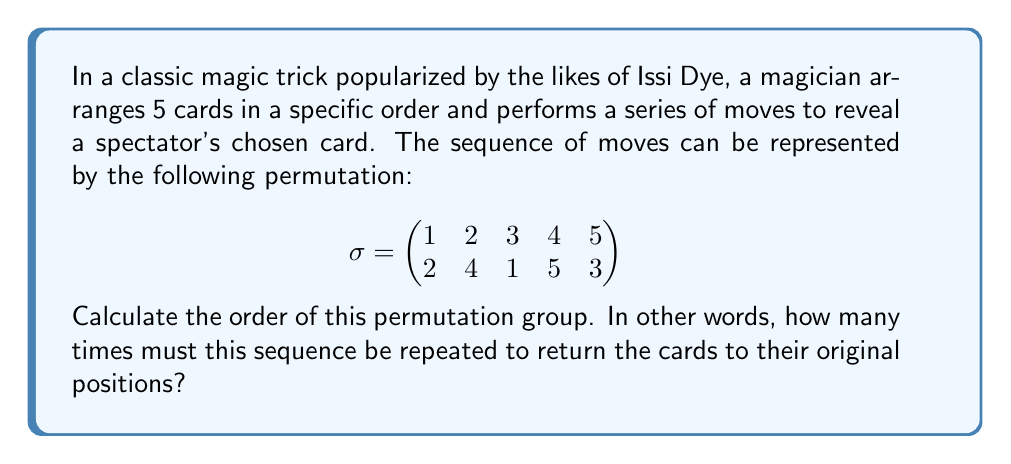What is the answer to this math problem? To find the order of the permutation group, we need to determine the least common multiple (LCM) of the cycle lengths in the permutation. Let's break this down step-by-step:

1) First, let's write the permutation in cycle notation:
   $\sigma = (1 2 4 5 3)$

2) We can see that this is a single cycle of length 5.

3) The order of a single cycle is equal to its length. In this case, the order is 5.

4) Since there's only one cycle, we don't need to calculate the LCM with any other cycle lengths.

5) Therefore, the permutation will return to the identity after being applied 5 times.

We can verify this:
$\sigma^1 = (1 2 4 5 3)$
$\sigma^2 = (1 4 3 2 5)$
$\sigma^3 = (1 5 2 3 4)$
$\sigma^4 = (1 3 5 4 2)$
$\sigma^5 = (1)(2)(3)(4)(5) = \text{identity}$

Thus, the order of the permutation group is 5.
Answer: 5 